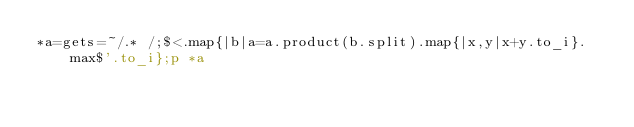Convert code to text. <code><loc_0><loc_0><loc_500><loc_500><_Ruby_>*a=gets=~/.* /;$<.map{|b|a=a.product(b.split).map{|x,y|x+y.to_i}.max$'.to_i};p *a</code> 